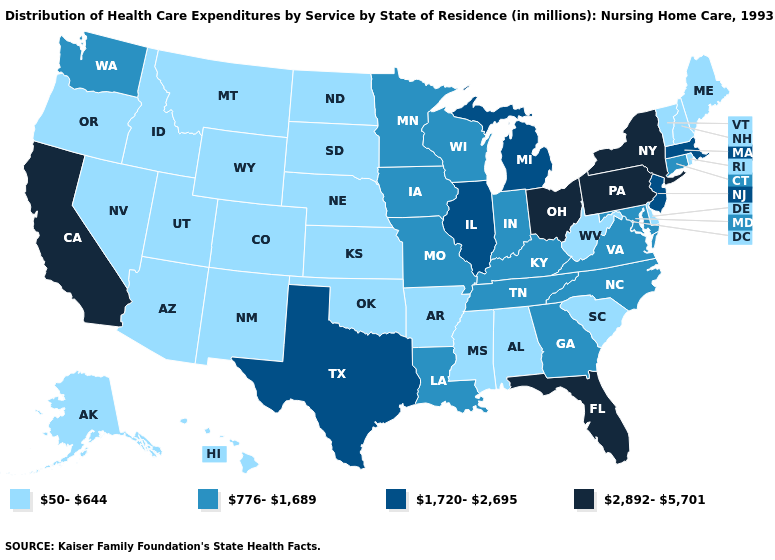What is the value of Alaska?
Keep it brief. 50-644. Does Hawaii have the highest value in the West?
Be succinct. No. What is the lowest value in states that border Texas?
Keep it brief. 50-644. Does Florida have the highest value in the USA?
Keep it brief. Yes. Among the states that border Kansas , which have the lowest value?
Give a very brief answer. Colorado, Nebraska, Oklahoma. Does the map have missing data?
Concise answer only. No. What is the highest value in the USA?
Keep it brief. 2,892-5,701. Does California have the lowest value in the USA?
Give a very brief answer. No. Does Minnesota have the highest value in the MidWest?
Keep it brief. No. Among the states that border Louisiana , which have the lowest value?
Write a very short answer. Arkansas, Mississippi. What is the highest value in the MidWest ?
Quick response, please. 2,892-5,701. Name the states that have a value in the range 2,892-5,701?
Quick response, please. California, Florida, New York, Ohio, Pennsylvania. What is the lowest value in the USA?
Be succinct. 50-644. What is the value of Nevada?
Be succinct. 50-644. What is the value of Utah?
Short answer required. 50-644. 